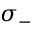<formula> <loc_0><loc_0><loc_500><loc_500>\sigma _ { - }</formula> 